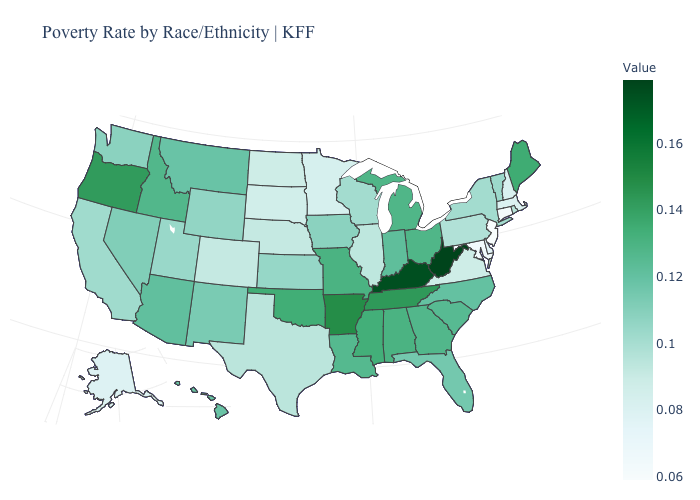Which states have the highest value in the USA?
Write a very short answer. West Virginia. Among the states that border New Mexico , which have the highest value?
Give a very brief answer. Oklahoma. 